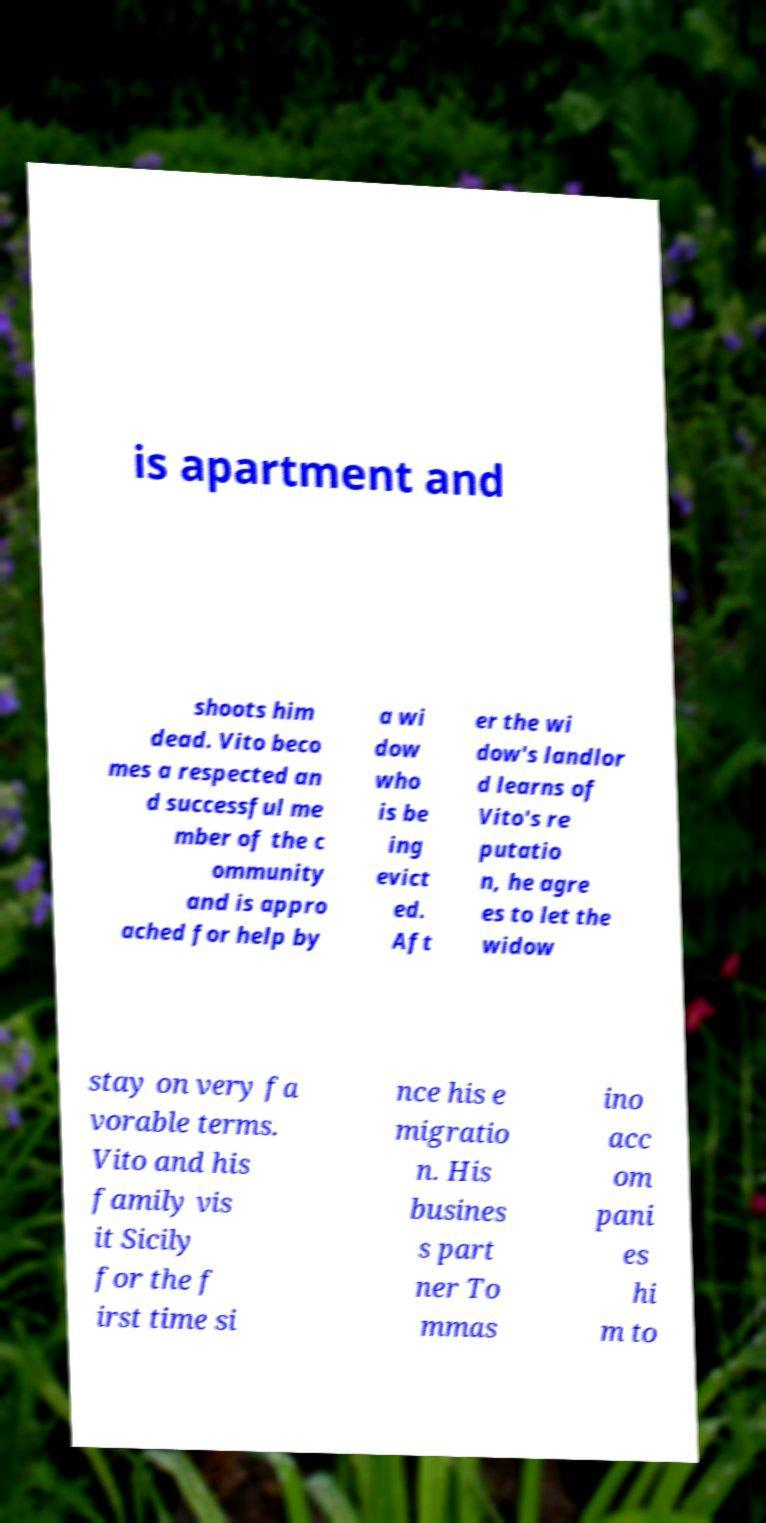I need the written content from this picture converted into text. Can you do that? is apartment and shoots him dead. Vito beco mes a respected an d successful me mber of the c ommunity and is appro ached for help by a wi dow who is be ing evict ed. Aft er the wi dow's landlor d learns of Vito's re putatio n, he agre es to let the widow stay on very fa vorable terms. Vito and his family vis it Sicily for the f irst time si nce his e migratio n. His busines s part ner To mmas ino acc om pani es hi m to 